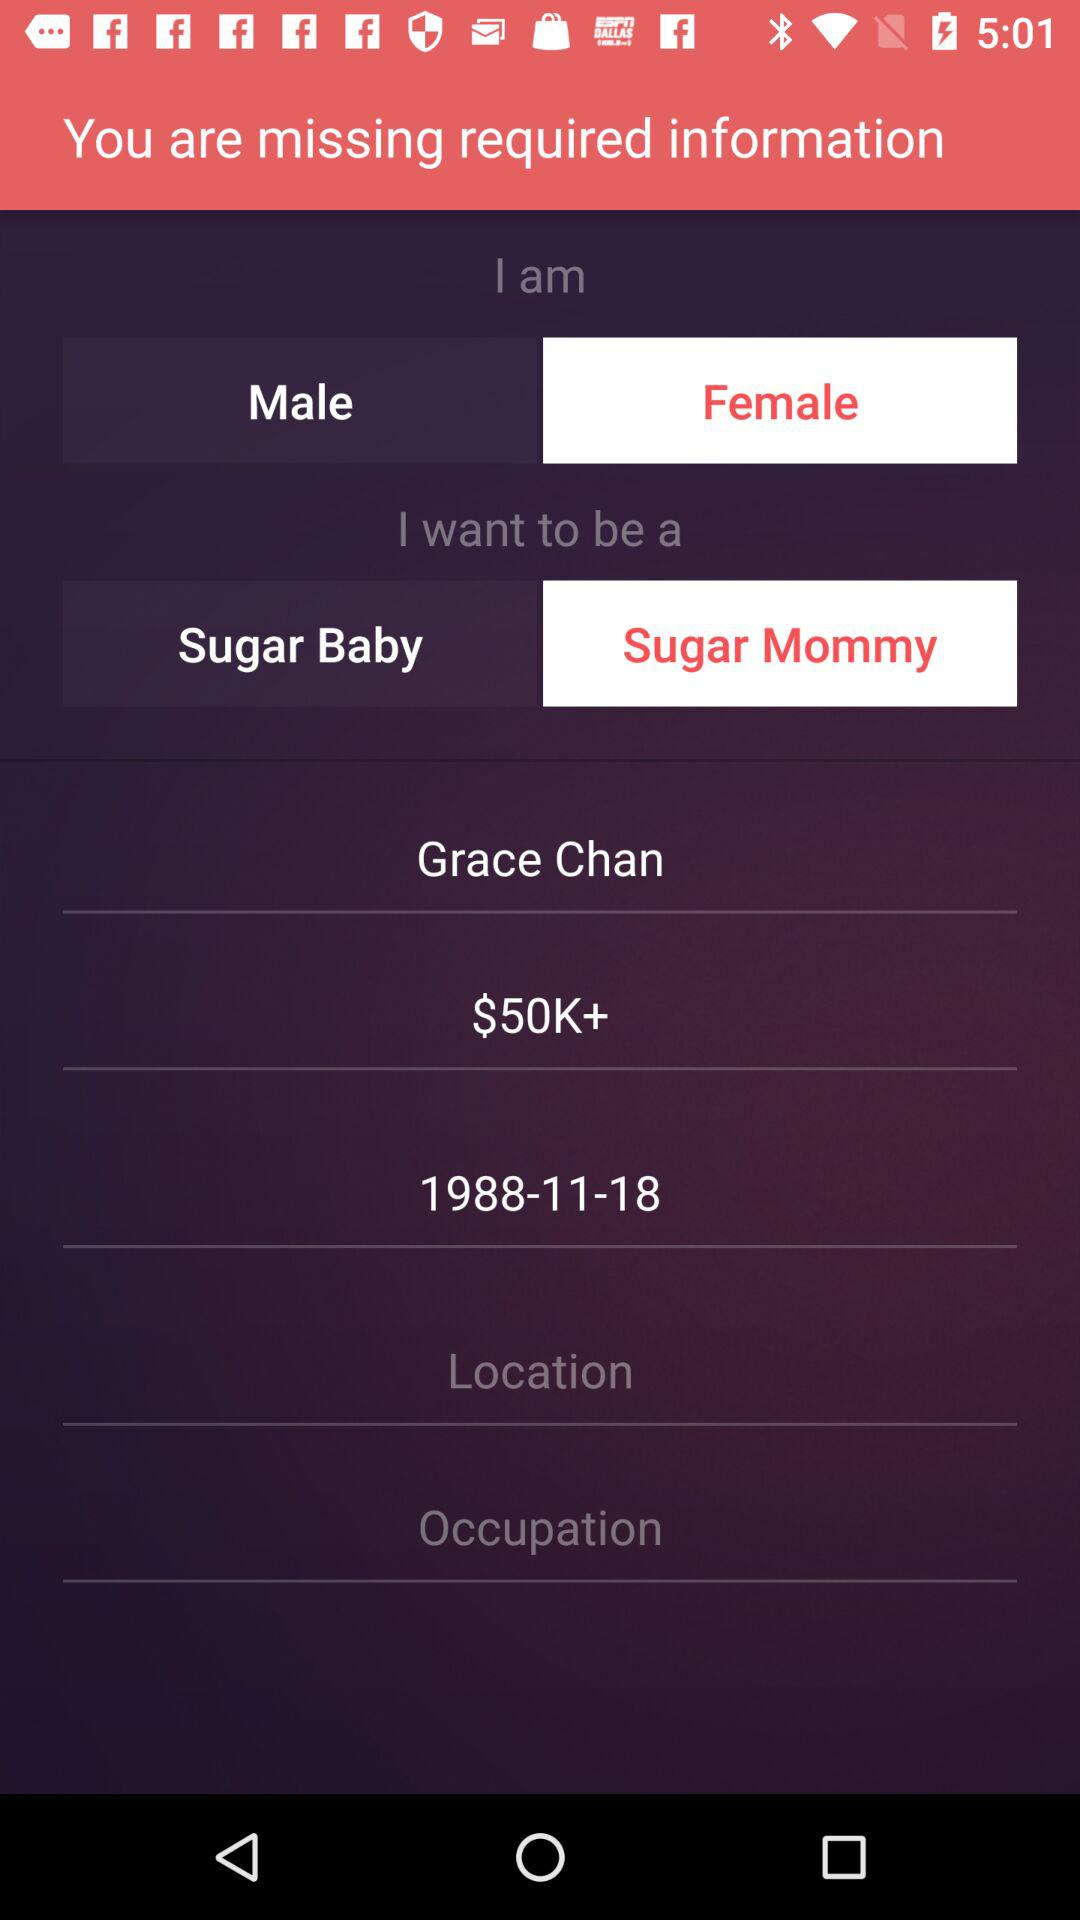What user want to be? The user wants to be a sugar mommy. 